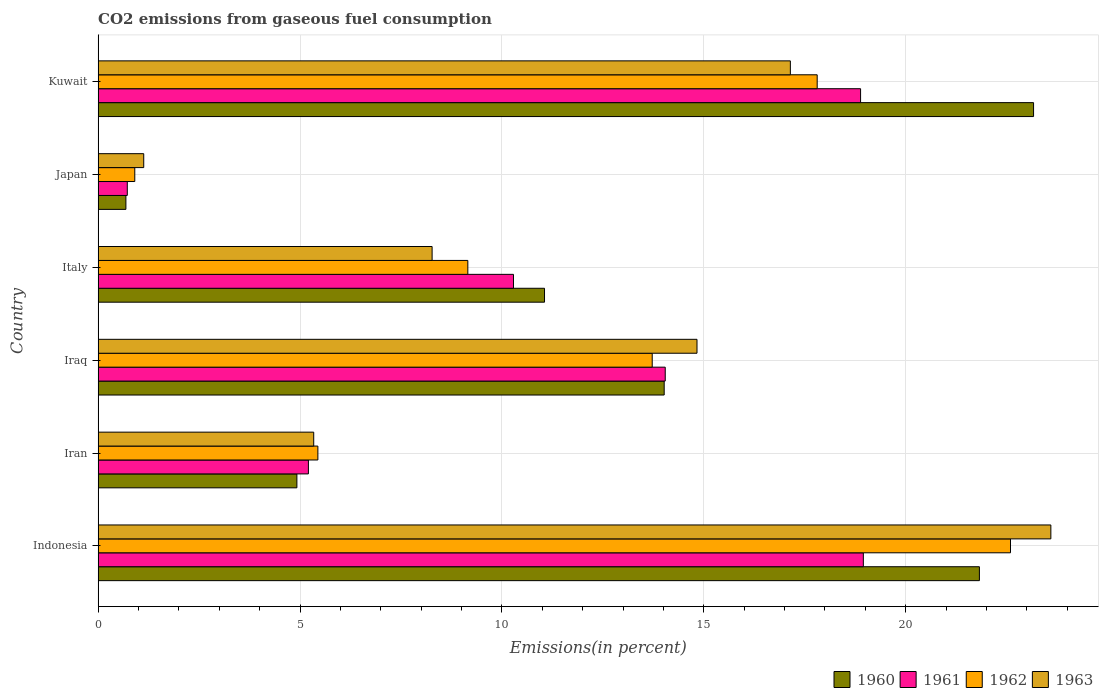How many different coloured bars are there?
Your response must be concise. 4. Are the number of bars on each tick of the Y-axis equal?
Give a very brief answer. Yes. How many bars are there on the 1st tick from the top?
Make the answer very short. 4. How many bars are there on the 5th tick from the bottom?
Provide a succinct answer. 4. What is the label of the 4th group of bars from the top?
Your answer should be very brief. Iraq. In how many cases, is the number of bars for a given country not equal to the number of legend labels?
Your answer should be compact. 0. What is the total CO2 emitted in 1963 in Italy?
Your answer should be compact. 8.27. Across all countries, what is the maximum total CO2 emitted in 1961?
Provide a succinct answer. 18.95. Across all countries, what is the minimum total CO2 emitted in 1960?
Your answer should be very brief. 0.69. In which country was the total CO2 emitted in 1962 maximum?
Your answer should be very brief. Indonesia. In which country was the total CO2 emitted in 1963 minimum?
Your answer should be compact. Japan. What is the total total CO2 emitted in 1960 in the graph?
Your answer should be very brief. 75.68. What is the difference between the total CO2 emitted in 1962 in Iran and that in Italy?
Ensure brevity in your answer.  -3.71. What is the difference between the total CO2 emitted in 1963 in Italy and the total CO2 emitted in 1961 in Indonesia?
Give a very brief answer. -10.68. What is the average total CO2 emitted in 1961 per country?
Provide a short and direct response. 11.35. What is the difference between the total CO2 emitted in 1962 and total CO2 emitted in 1961 in Kuwait?
Your answer should be very brief. -1.07. What is the ratio of the total CO2 emitted in 1960 in Japan to that in Kuwait?
Provide a succinct answer. 0.03. Is the difference between the total CO2 emitted in 1962 in Iran and Kuwait greater than the difference between the total CO2 emitted in 1961 in Iran and Kuwait?
Make the answer very short. Yes. What is the difference between the highest and the second highest total CO2 emitted in 1961?
Make the answer very short. 0.07. What is the difference between the highest and the lowest total CO2 emitted in 1961?
Provide a succinct answer. 18.23. In how many countries, is the total CO2 emitted in 1962 greater than the average total CO2 emitted in 1962 taken over all countries?
Your answer should be compact. 3. What does the 3rd bar from the bottom in Indonesia represents?
Provide a succinct answer. 1962. Is it the case that in every country, the sum of the total CO2 emitted in 1963 and total CO2 emitted in 1960 is greater than the total CO2 emitted in 1962?
Make the answer very short. Yes. Are all the bars in the graph horizontal?
Keep it short and to the point. Yes. How many countries are there in the graph?
Make the answer very short. 6. Are the values on the major ticks of X-axis written in scientific E-notation?
Offer a very short reply. No. Does the graph contain any zero values?
Ensure brevity in your answer.  No. How are the legend labels stacked?
Offer a very short reply. Horizontal. What is the title of the graph?
Make the answer very short. CO2 emissions from gaseous fuel consumption. What is the label or title of the X-axis?
Provide a succinct answer. Emissions(in percent). What is the label or title of the Y-axis?
Offer a very short reply. Country. What is the Emissions(in percent) in 1960 in Indonesia?
Provide a succinct answer. 21.83. What is the Emissions(in percent) in 1961 in Indonesia?
Your response must be concise. 18.95. What is the Emissions(in percent) in 1962 in Indonesia?
Ensure brevity in your answer.  22.6. What is the Emissions(in percent) in 1963 in Indonesia?
Provide a succinct answer. 23.6. What is the Emissions(in percent) of 1960 in Iran?
Your answer should be very brief. 4.92. What is the Emissions(in percent) in 1961 in Iran?
Keep it short and to the point. 5.21. What is the Emissions(in percent) of 1962 in Iran?
Your response must be concise. 5.44. What is the Emissions(in percent) in 1963 in Iran?
Provide a succinct answer. 5.34. What is the Emissions(in percent) in 1960 in Iraq?
Provide a succinct answer. 14.02. What is the Emissions(in percent) in 1961 in Iraq?
Offer a terse response. 14.05. What is the Emissions(in percent) of 1962 in Iraq?
Your answer should be very brief. 13.72. What is the Emissions(in percent) in 1963 in Iraq?
Make the answer very short. 14.83. What is the Emissions(in percent) in 1960 in Italy?
Your answer should be very brief. 11.06. What is the Emissions(in percent) in 1961 in Italy?
Ensure brevity in your answer.  10.29. What is the Emissions(in percent) in 1962 in Italy?
Keep it short and to the point. 9.16. What is the Emissions(in percent) of 1963 in Italy?
Offer a terse response. 8.27. What is the Emissions(in percent) in 1960 in Japan?
Keep it short and to the point. 0.69. What is the Emissions(in percent) of 1961 in Japan?
Provide a short and direct response. 0.72. What is the Emissions(in percent) of 1962 in Japan?
Offer a very short reply. 0.91. What is the Emissions(in percent) in 1963 in Japan?
Ensure brevity in your answer.  1.13. What is the Emissions(in percent) of 1960 in Kuwait?
Offer a terse response. 23.17. What is the Emissions(in percent) of 1961 in Kuwait?
Keep it short and to the point. 18.88. What is the Emissions(in percent) of 1962 in Kuwait?
Give a very brief answer. 17.81. What is the Emissions(in percent) of 1963 in Kuwait?
Provide a succinct answer. 17.14. Across all countries, what is the maximum Emissions(in percent) of 1960?
Your response must be concise. 23.17. Across all countries, what is the maximum Emissions(in percent) in 1961?
Make the answer very short. 18.95. Across all countries, what is the maximum Emissions(in percent) of 1962?
Ensure brevity in your answer.  22.6. Across all countries, what is the maximum Emissions(in percent) in 1963?
Keep it short and to the point. 23.6. Across all countries, what is the minimum Emissions(in percent) in 1960?
Make the answer very short. 0.69. Across all countries, what is the minimum Emissions(in percent) in 1961?
Provide a short and direct response. 0.72. Across all countries, what is the minimum Emissions(in percent) of 1962?
Offer a very short reply. 0.91. Across all countries, what is the minimum Emissions(in percent) of 1963?
Provide a succinct answer. 1.13. What is the total Emissions(in percent) of 1960 in the graph?
Offer a very short reply. 75.68. What is the total Emissions(in percent) in 1961 in the graph?
Offer a terse response. 68.1. What is the total Emissions(in percent) of 1962 in the graph?
Provide a short and direct response. 69.63. What is the total Emissions(in percent) in 1963 in the graph?
Your answer should be very brief. 70.31. What is the difference between the Emissions(in percent) in 1960 in Indonesia and that in Iran?
Make the answer very short. 16.9. What is the difference between the Emissions(in percent) of 1961 in Indonesia and that in Iran?
Offer a terse response. 13.74. What is the difference between the Emissions(in percent) in 1962 in Indonesia and that in Iran?
Offer a very short reply. 17.15. What is the difference between the Emissions(in percent) of 1963 in Indonesia and that in Iran?
Ensure brevity in your answer.  18.26. What is the difference between the Emissions(in percent) in 1960 in Indonesia and that in Iraq?
Offer a very short reply. 7.81. What is the difference between the Emissions(in percent) in 1961 in Indonesia and that in Iraq?
Provide a succinct answer. 4.91. What is the difference between the Emissions(in percent) in 1962 in Indonesia and that in Iraq?
Provide a short and direct response. 8.87. What is the difference between the Emissions(in percent) of 1963 in Indonesia and that in Iraq?
Keep it short and to the point. 8.76. What is the difference between the Emissions(in percent) of 1960 in Indonesia and that in Italy?
Keep it short and to the point. 10.77. What is the difference between the Emissions(in percent) in 1961 in Indonesia and that in Italy?
Offer a very short reply. 8.66. What is the difference between the Emissions(in percent) in 1962 in Indonesia and that in Italy?
Your response must be concise. 13.44. What is the difference between the Emissions(in percent) in 1963 in Indonesia and that in Italy?
Your answer should be very brief. 15.32. What is the difference between the Emissions(in percent) in 1960 in Indonesia and that in Japan?
Offer a terse response. 21.14. What is the difference between the Emissions(in percent) in 1961 in Indonesia and that in Japan?
Make the answer very short. 18.23. What is the difference between the Emissions(in percent) in 1962 in Indonesia and that in Japan?
Provide a succinct answer. 21.69. What is the difference between the Emissions(in percent) in 1963 in Indonesia and that in Japan?
Your answer should be very brief. 22.47. What is the difference between the Emissions(in percent) of 1960 in Indonesia and that in Kuwait?
Ensure brevity in your answer.  -1.34. What is the difference between the Emissions(in percent) of 1961 in Indonesia and that in Kuwait?
Make the answer very short. 0.07. What is the difference between the Emissions(in percent) of 1962 in Indonesia and that in Kuwait?
Offer a very short reply. 4.79. What is the difference between the Emissions(in percent) of 1963 in Indonesia and that in Kuwait?
Your response must be concise. 6.45. What is the difference between the Emissions(in percent) of 1960 in Iran and that in Iraq?
Your answer should be compact. -9.1. What is the difference between the Emissions(in percent) of 1961 in Iran and that in Iraq?
Your answer should be compact. -8.84. What is the difference between the Emissions(in percent) in 1962 in Iran and that in Iraq?
Offer a very short reply. -8.28. What is the difference between the Emissions(in percent) of 1963 in Iran and that in Iraq?
Your answer should be very brief. -9.49. What is the difference between the Emissions(in percent) in 1960 in Iran and that in Italy?
Offer a terse response. -6.13. What is the difference between the Emissions(in percent) in 1961 in Iran and that in Italy?
Make the answer very short. -5.08. What is the difference between the Emissions(in percent) of 1962 in Iran and that in Italy?
Your response must be concise. -3.71. What is the difference between the Emissions(in percent) of 1963 in Iran and that in Italy?
Your answer should be very brief. -2.93. What is the difference between the Emissions(in percent) in 1960 in Iran and that in Japan?
Provide a succinct answer. 4.23. What is the difference between the Emissions(in percent) of 1961 in Iran and that in Japan?
Keep it short and to the point. 4.49. What is the difference between the Emissions(in percent) of 1962 in Iran and that in Japan?
Provide a short and direct response. 4.53. What is the difference between the Emissions(in percent) of 1963 in Iran and that in Japan?
Provide a succinct answer. 4.21. What is the difference between the Emissions(in percent) in 1960 in Iran and that in Kuwait?
Provide a short and direct response. -18.24. What is the difference between the Emissions(in percent) in 1961 in Iran and that in Kuwait?
Offer a very short reply. -13.67. What is the difference between the Emissions(in percent) of 1962 in Iran and that in Kuwait?
Give a very brief answer. -12.37. What is the difference between the Emissions(in percent) in 1963 in Iran and that in Kuwait?
Offer a very short reply. -11.8. What is the difference between the Emissions(in percent) of 1960 in Iraq and that in Italy?
Ensure brevity in your answer.  2.96. What is the difference between the Emissions(in percent) of 1961 in Iraq and that in Italy?
Your response must be concise. 3.76. What is the difference between the Emissions(in percent) of 1962 in Iraq and that in Italy?
Give a very brief answer. 4.57. What is the difference between the Emissions(in percent) in 1963 in Iraq and that in Italy?
Your response must be concise. 6.56. What is the difference between the Emissions(in percent) of 1960 in Iraq and that in Japan?
Offer a terse response. 13.33. What is the difference between the Emissions(in percent) in 1961 in Iraq and that in Japan?
Provide a short and direct response. 13.32. What is the difference between the Emissions(in percent) in 1962 in Iraq and that in Japan?
Your answer should be very brief. 12.82. What is the difference between the Emissions(in percent) of 1963 in Iraq and that in Japan?
Your response must be concise. 13.7. What is the difference between the Emissions(in percent) of 1960 in Iraq and that in Kuwait?
Offer a very short reply. -9.15. What is the difference between the Emissions(in percent) in 1961 in Iraq and that in Kuwait?
Give a very brief answer. -4.84. What is the difference between the Emissions(in percent) of 1962 in Iraq and that in Kuwait?
Keep it short and to the point. -4.09. What is the difference between the Emissions(in percent) of 1963 in Iraq and that in Kuwait?
Offer a very short reply. -2.31. What is the difference between the Emissions(in percent) of 1960 in Italy and that in Japan?
Offer a very short reply. 10.37. What is the difference between the Emissions(in percent) of 1961 in Italy and that in Japan?
Your answer should be compact. 9.56. What is the difference between the Emissions(in percent) in 1962 in Italy and that in Japan?
Make the answer very short. 8.25. What is the difference between the Emissions(in percent) in 1963 in Italy and that in Japan?
Offer a very short reply. 7.14. What is the difference between the Emissions(in percent) of 1960 in Italy and that in Kuwait?
Your answer should be compact. -12.11. What is the difference between the Emissions(in percent) in 1961 in Italy and that in Kuwait?
Make the answer very short. -8.6. What is the difference between the Emissions(in percent) in 1962 in Italy and that in Kuwait?
Give a very brief answer. -8.65. What is the difference between the Emissions(in percent) of 1963 in Italy and that in Kuwait?
Give a very brief answer. -8.87. What is the difference between the Emissions(in percent) of 1960 in Japan and that in Kuwait?
Give a very brief answer. -22.48. What is the difference between the Emissions(in percent) of 1961 in Japan and that in Kuwait?
Provide a short and direct response. -18.16. What is the difference between the Emissions(in percent) of 1962 in Japan and that in Kuwait?
Offer a terse response. -16.9. What is the difference between the Emissions(in percent) in 1963 in Japan and that in Kuwait?
Keep it short and to the point. -16.01. What is the difference between the Emissions(in percent) of 1960 in Indonesia and the Emissions(in percent) of 1961 in Iran?
Your response must be concise. 16.62. What is the difference between the Emissions(in percent) of 1960 in Indonesia and the Emissions(in percent) of 1962 in Iran?
Make the answer very short. 16.38. What is the difference between the Emissions(in percent) of 1960 in Indonesia and the Emissions(in percent) of 1963 in Iran?
Your response must be concise. 16.49. What is the difference between the Emissions(in percent) of 1961 in Indonesia and the Emissions(in percent) of 1962 in Iran?
Your response must be concise. 13.51. What is the difference between the Emissions(in percent) of 1961 in Indonesia and the Emissions(in percent) of 1963 in Iran?
Offer a terse response. 13.61. What is the difference between the Emissions(in percent) of 1962 in Indonesia and the Emissions(in percent) of 1963 in Iran?
Provide a short and direct response. 17.26. What is the difference between the Emissions(in percent) of 1960 in Indonesia and the Emissions(in percent) of 1961 in Iraq?
Provide a succinct answer. 7.78. What is the difference between the Emissions(in percent) of 1960 in Indonesia and the Emissions(in percent) of 1962 in Iraq?
Provide a short and direct response. 8.1. What is the difference between the Emissions(in percent) of 1960 in Indonesia and the Emissions(in percent) of 1963 in Iraq?
Make the answer very short. 6.99. What is the difference between the Emissions(in percent) of 1961 in Indonesia and the Emissions(in percent) of 1962 in Iraq?
Offer a very short reply. 5.23. What is the difference between the Emissions(in percent) in 1961 in Indonesia and the Emissions(in percent) in 1963 in Iraq?
Ensure brevity in your answer.  4.12. What is the difference between the Emissions(in percent) of 1962 in Indonesia and the Emissions(in percent) of 1963 in Iraq?
Provide a short and direct response. 7.76. What is the difference between the Emissions(in percent) in 1960 in Indonesia and the Emissions(in percent) in 1961 in Italy?
Provide a succinct answer. 11.54. What is the difference between the Emissions(in percent) in 1960 in Indonesia and the Emissions(in percent) in 1962 in Italy?
Give a very brief answer. 12.67. What is the difference between the Emissions(in percent) of 1960 in Indonesia and the Emissions(in percent) of 1963 in Italy?
Your answer should be very brief. 13.55. What is the difference between the Emissions(in percent) in 1961 in Indonesia and the Emissions(in percent) in 1962 in Italy?
Your answer should be compact. 9.8. What is the difference between the Emissions(in percent) in 1961 in Indonesia and the Emissions(in percent) in 1963 in Italy?
Provide a succinct answer. 10.68. What is the difference between the Emissions(in percent) of 1962 in Indonesia and the Emissions(in percent) of 1963 in Italy?
Provide a succinct answer. 14.32. What is the difference between the Emissions(in percent) in 1960 in Indonesia and the Emissions(in percent) in 1961 in Japan?
Keep it short and to the point. 21.1. What is the difference between the Emissions(in percent) in 1960 in Indonesia and the Emissions(in percent) in 1962 in Japan?
Give a very brief answer. 20.92. What is the difference between the Emissions(in percent) of 1960 in Indonesia and the Emissions(in percent) of 1963 in Japan?
Your response must be concise. 20.7. What is the difference between the Emissions(in percent) in 1961 in Indonesia and the Emissions(in percent) in 1962 in Japan?
Your response must be concise. 18.04. What is the difference between the Emissions(in percent) of 1961 in Indonesia and the Emissions(in percent) of 1963 in Japan?
Your answer should be compact. 17.82. What is the difference between the Emissions(in percent) of 1962 in Indonesia and the Emissions(in percent) of 1963 in Japan?
Make the answer very short. 21.47. What is the difference between the Emissions(in percent) of 1960 in Indonesia and the Emissions(in percent) of 1961 in Kuwait?
Provide a succinct answer. 2.94. What is the difference between the Emissions(in percent) of 1960 in Indonesia and the Emissions(in percent) of 1962 in Kuwait?
Your response must be concise. 4.02. What is the difference between the Emissions(in percent) of 1960 in Indonesia and the Emissions(in percent) of 1963 in Kuwait?
Make the answer very short. 4.68. What is the difference between the Emissions(in percent) in 1961 in Indonesia and the Emissions(in percent) in 1962 in Kuwait?
Ensure brevity in your answer.  1.14. What is the difference between the Emissions(in percent) of 1961 in Indonesia and the Emissions(in percent) of 1963 in Kuwait?
Provide a short and direct response. 1.81. What is the difference between the Emissions(in percent) of 1962 in Indonesia and the Emissions(in percent) of 1963 in Kuwait?
Your answer should be very brief. 5.45. What is the difference between the Emissions(in percent) of 1960 in Iran and the Emissions(in percent) of 1961 in Iraq?
Provide a succinct answer. -9.12. What is the difference between the Emissions(in percent) in 1960 in Iran and the Emissions(in percent) in 1962 in Iraq?
Offer a very short reply. -8.8. What is the difference between the Emissions(in percent) in 1960 in Iran and the Emissions(in percent) in 1963 in Iraq?
Your answer should be compact. -9.91. What is the difference between the Emissions(in percent) of 1961 in Iran and the Emissions(in percent) of 1962 in Iraq?
Your answer should be very brief. -8.51. What is the difference between the Emissions(in percent) in 1961 in Iran and the Emissions(in percent) in 1963 in Iraq?
Your answer should be compact. -9.62. What is the difference between the Emissions(in percent) of 1962 in Iran and the Emissions(in percent) of 1963 in Iraq?
Ensure brevity in your answer.  -9.39. What is the difference between the Emissions(in percent) of 1960 in Iran and the Emissions(in percent) of 1961 in Italy?
Your answer should be compact. -5.36. What is the difference between the Emissions(in percent) in 1960 in Iran and the Emissions(in percent) in 1962 in Italy?
Offer a terse response. -4.23. What is the difference between the Emissions(in percent) of 1960 in Iran and the Emissions(in percent) of 1963 in Italy?
Your answer should be very brief. -3.35. What is the difference between the Emissions(in percent) in 1961 in Iran and the Emissions(in percent) in 1962 in Italy?
Offer a terse response. -3.95. What is the difference between the Emissions(in percent) in 1961 in Iran and the Emissions(in percent) in 1963 in Italy?
Offer a terse response. -3.06. What is the difference between the Emissions(in percent) in 1962 in Iran and the Emissions(in percent) in 1963 in Italy?
Your response must be concise. -2.83. What is the difference between the Emissions(in percent) in 1960 in Iran and the Emissions(in percent) in 1961 in Japan?
Your answer should be very brief. 4.2. What is the difference between the Emissions(in percent) in 1960 in Iran and the Emissions(in percent) in 1962 in Japan?
Your answer should be very brief. 4.02. What is the difference between the Emissions(in percent) of 1960 in Iran and the Emissions(in percent) of 1963 in Japan?
Provide a succinct answer. 3.79. What is the difference between the Emissions(in percent) in 1961 in Iran and the Emissions(in percent) in 1962 in Japan?
Your answer should be compact. 4.3. What is the difference between the Emissions(in percent) in 1961 in Iran and the Emissions(in percent) in 1963 in Japan?
Ensure brevity in your answer.  4.08. What is the difference between the Emissions(in percent) of 1962 in Iran and the Emissions(in percent) of 1963 in Japan?
Your response must be concise. 4.31. What is the difference between the Emissions(in percent) of 1960 in Iran and the Emissions(in percent) of 1961 in Kuwait?
Ensure brevity in your answer.  -13.96. What is the difference between the Emissions(in percent) of 1960 in Iran and the Emissions(in percent) of 1962 in Kuwait?
Give a very brief answer. -12.89. What is the difference between the Emissions(in percent) of 1960 in Iran and the Emissions(in percent) of 1963 in Kuwait?
Provide a short and direct response. -12.22. What is the difference between the Emissions(in percent) of 1961 in Iran and the Emissions(in percent) of 1962 in Kuwait?
Your answer should be very brief. -12.6. What is the difference between the Emissions(in percent) in 1961 in Iran and the Emissions(in percent) in 1963 in Kuwait?
Your answer should be very brief. -11.94. What is the difference between the Emissions(in percent) of 1962 in Iran and the Emissions(in percent) of 1963 in Kuwait?
Your answer should be very brief. -11.7. What is the difference between the Emissions(in percent) in 1960 in Iraq and the Emissions(in percent) in 1961 in Italy?
Provide a short and direct response. 3.73. What is the difference between the Emissions(in percent) in 1960 in Iraq and the Emissions(in percent) in 1962 in Italy?
Give a very brief answer. 4.86. What is the difference between the Emissions(in percent) in 1960 in Iraq and the Emissions(in percent) in 1963 in Italy?
Ensure brevity in your answer.  5.75. What is the difference between the Emissions(in percent) in 1961 in Iraq and the Emissions(in percent) in 1962 in Italy?
Provide a short and direct response. 4.89. What is the difference between the Emissions(in percent) in 1961 in Iraq and the Emissions(in percent) in 1963 in Italy?
Your answer should be very brief. 5.77. What is the difference between the Emissions(in percent) of 1962 in Iraq and the Emissions(in percent) of 1963 in Italy?
Make the answer very short. 5.45. What is the difference between the Emissions(in percent) in 1960 in Iraq and the Emissions(in percent) in 1961 in Japan?
Your response must be concise. 13.3. What is the difference between the Emissions(in percent) in 1960 in Iraq and the Emissions(in percent) in 1962 in Japan?
Your answer should be very brief. 13.11. What is the difference between the Emissions(in percent) of 1960 in Iraq and the Emissions(in percent) of 1963 in Japan?
Offer a terse response. 12.89. What is the difference between the Emissions(in percent) in 1961 in Iraq and the Emissions(in percent) in 1962 in Japan?
Your answer should be very brief. 13.14. What is the difference between the Emissions(in percent) in 1961 in Iraq and the Emissions(in percent) in 1963 in Japan?
Your response must be concise. 12.92. What is the difference between the Emissions(in percent) in 1962 in Iraq and the Emissions(in percent) in 1963 in Japan?
Ensure brevity in your answer.  12.59. What is the difference between the Emissions(in percent) of 1960 in Iraq and the Emissions(in percent) of 1961 in Kuwait?
Your answer should be very brief. -4.86. What is the difference between the Emissions(in percent) of 1960 in Iraq and the Emissions(in percent) of 1962 in Kuwait?
Ensure brevity in your answer.  -3.79. What is the difference between the Emissions(in percent) of 1960 in Iraq and the Emissions(in percent) of 1963 in Kuwait?
Offer a very short reply. -3.12. What is the difference between the Emissions(in percent) in 1961 in Iraq and the Emissions(in percent) in 1962 in Kuwait?
Your response must be concise. -3.76. What is the difference between the Emissions(in percent) of 1961 in Iraq and the Emissions(in percent) of 1963 in Kuwait?
Offer a very short reply. -3.1. What is the difference between the Emissions(in percent) of 1962 in Iraq and the Emissions(in percent) of 1963 in Kuwait?
Provide a succinct answer. -3.42. What is the difference between the Emissions(in percent) in 1960 in Italy and the Emissions(in percent) in 1961 in Japan?
Your answer should be very brief. 10.33. What is the difference between the Emissions(in percent) in 1960 in Italy and the Emissions(in percent) in 1962 in Japan?
Offer a terse response. 10.15. What is the difference between the Emissions(in percent) in 1960 in Italy and the Emissions(in percent) in 1963 in Japan?
Provide a short and direct response. 9.93. What is the difference between the Emissions(in percent) of 1961 in Italy and the Emissions(in percent) of 1962 in Japan?
Your response must be concise. 9.38. What is the difference between the Emissions(in percent) of 1961 in Italy and the Emissions(in percent) of 1963 in Japan?
Ensure brevity in your answer.  9.16. What is the difference between the Emissions(in percent) of 1962 in Italy and the Emissions(in percent) of 1963 in Japan?
Keep it short and to the point. 8.03. What is the difference between the Emissions(in percent) in 1960 in Italy and the Emissions(in percent) in 1961 in Kuwait?
Provide a short and direct response. -7.83. What is the difference between the Emissions(in percent) of 1960 in Italy and the Emissions(in percent) of 1962 in Kuwait?
Your answer should be compact. -6.75. What is the difference between the Emissions(in percent) in 1960 in Italy and the Emissions(in percent) in 1963 in Kuwait?
Your answer should be very brief. -6.09. What is the difference between the Emissions(in percent) in 1961 in Italy and the Emissions(in percent) in 1962 in Kuwait?
Make the answer very short. -7.52. What is the difference between the Emissions(in percent) of 1961 in Italy and the Emissions(in percent) of 1963 in Kuwait?
Keep it short and to the point. -6.86. What is the difference between the Emissions(in percent) in 1962 in Italy and the Emissions(in percent) in 1963 in Kuwait?
Your answer should be very brief. -7.99. What is the difference between the Emissions(in percent) of 1960 in Japan and the Emissions(in percent) of 1961 in Kuwait?
Make the answer very short. -18.19. What is the difference between the Emissions(in percent) of 1960 in Japan and the Emissions(in percent) of 1962 in Kuwait?
Your response must be concise. -17.12. What is the difference between the Emissions(in percent) of 1960 in Japan and the Emissions(in percent) of 1963 in Kuwait?
Your response must be concise. -16.46. What is the difference between the Emissions(in percent) of 1961 in Japan and the Emissions(in percent) of 1962 in Kuwait?
Provide a succinct answer. -17.09. What is the difference between the Emissions(in percent) in 1961 in Japan and the Emissions(in percent) in 1963 in Kuwait?
Ensure brevity in your answer.  -16.42. What is the difference between the Emissions(in percent) in 1962 in Japan and the Emissions(in percent) in 1963 in Kuwait?
Offer a very short reply. -16.24. What is the average Emissions(in percent) in 1960 per country?
Offer a very short reply. 12.61. What is the average Emissions(in percent) of 1961 per country?
Provide a succinct answer. 11.35. What is the average Emissions(in percent) of 1962 per country?
Keep it short and to the point. 11.61. What is the average Emissions(in percent) in 1963 per country?
Make the answer very short. 11.72. What is the difference between the Emissions(in percent) of 1960 and Emissions(in percent) of 1961 in Indonesia?
Provide a succinct answer. 2.87. What is the difference between the Emissions(in percent) of 1960 and Emissions(in percent) of 1962 in Indonesia?
Your response must be concise. -0.77. What is the difference between the Emissions(in percent) of 1960 and Emissions(in percent) of 1963 in Indonesia?
Ensure brevity in your answer.  -1.77. What is the difference between the Emissions(in percent) of 1961 and Emissions(in percent) of 1962 in Indonesia?
Provide a succinct answer. -3.64. What is the difference between the Emissions(in percent) in 1961 and Emissions(in percent) in 1963 in Indonesia?
Keep it short and to the point. -4.64. What is the difference between the Emissions(in percent) of 1962 and Emissions(in percent) of 1963 in Indonesia?
Give a very brief answer. -1. What is the difference between the Emissions(in percent) in 1960 and Emissions(in percent) in 1961 in Iran?
Give a very brief answer. -0.29. What is the difference between the Emissions(in percent) of 1960 and Emissions(in percent) of 1962 in Iran?
Your response must be concise. -0.52. What is the difference between the Emissions(in percent) in 1960 and Emissions(in percent) in 1963 in Iran?
Offer a terse response. -0.42. What is the difference between the Emissions(in percent) in 1961 and Emissions(in percent) in 1962 in Iran?
Keep it short and to the point. -0.23. What is the difference between the Emissions(in percent) in 1961 and Emissions(in percent) in 1963 in Iran?
Your response must be concise. -0.13. What is the difference between the Emissions(in percent) of 1962 and Emissions(in percent) of 1963 in Iran?
Your answer should be very brief. 0.1. What is the difference between the Emissions(in percent) of 1960 and Emissions(in percent) of 1961 in Iraq?
Provide a succinct answer. -0.03. What is the difference between the Emissions(in percent) in 1960 and Emissions(in percent) in 1962 in Iraq?
Offer a very short reply. 0.3. What is the difference between the Emissions(in percent) in 1960 and Emissions(in percent) in 1963 in Iraq?
Keep it short and to the point. -0.81. What is the difference between the Emissions(in percent) of 1961 and Emissions(in percent) of 1962 in Iraq?
Your answer should be compact. 0.32. What is the difference between the Emissions(in percent) in 1961 and Emissions(in percent) in 1963 in Iraq?
Provide a succinct answer. -0.79. What is the difference between the Emissions(in percent) in 1962 and Emissions(in percent) in 1963 in Iraq?
Give a very brief answer. -1.11. What is the difference between the Emissions(in percent) in 1960 and Emissions(in percent) in 1961 in Italy?
Provide a short and direct response. 0.77. What is the difference between the Emissions(in percent) of 1960 and Emissions(in percent) of 1962 in Italy?
Your response must be concise. 1.9. What is the difference between the Emissions(in percent) in 1960 and Emissions(in percent) in 1963 in Italy?
Your response must be concise. 2.78. What is the difference between the Emissions(in percent) of 1961 and Emissions(in percent) of 1962 in Italy?
Ensure brevity in your answer.  1.13. What is the difference between the Emissions(in percent) in 1961 and Emissions(in percent) in 1963 in Italy?
Offer a very short reply. 2.02. What is the difference between the Emissions(in percent) in 1962 and Emissions(in percent) in 1963 in Italy?
Your answer should be very brief. 0.88. What is the difference between the Emissions(in percent) of 1960 and Emissions(in percent) of 1961 in Japan?
Provide a short and direct response. -0.03. What is the difference between the Emissions(in percent) of 1960 and Emissions(in percent) of 1962 in Japan?
Make the answer very short. -0.22. What is the difference between the Emissions(in percent) of 1960 and Emissions(in percent) of 1963 in Japan?
Ensure brevity in your answer.  -0.44. What is the difference between the Emissions(in percent) of 1961 and Emissions(in percent) of 1962 in Japan?
Your response must be concise. -0.19. What is the difference between the Emissions(in percent) of 1961 and Emissions(in percent) of 1963 in Japan?
Offer a terse response. -0.41. What is the difference between the Emissions(in percent) in 1962 and Emissions(in percent) in 1963 in Japan?
Your answer should be very brief. -0.22. What is the difference between the Emissions(in percent) of 1960 and Emissions(in percent) of 1961 in Kuwait?
Offer a very short reply. 4.28. What is the difference between the Emissions(in percent) of 1960 and Emissions(in percent) of 1962 in Kuwait?
Provide a succinct answer. 5.36. What is the difference between the Emissions(in percent) in 1960 and Emissions(in percent) in 1963 in Kuwait?
Give a very brief answer. 6.02. What is the difference between the Emissions(in percent) in 1961 and Emissions(in percent) in 1962 in Kuwait?
Your response must be concise. 1.07. What is the difference between the Emissions(in percent) in 1961 and Emissions(in percent) in 1963 in Kuwait?
Your response must be concise. 1.74. What is the difference between the Emissions(in percent) in 1962 and Emissions(in percent) in 1963 in Kuwait?
Keep it short and to the point. 0.66. What is the ratio of the Emissions(in percent) in 1960 in Indonesia to that in Iran?
Your response must be concise. 4.43. What is the ratio of the Emissions(in percent) of 1961 in Indonesia to that in Iran?
Provide a short and direct response. 3.64. What is the ratio of the Emissions(in percent) of 1962 in Indonesia to that in Iran?
Provide a succinct answer. 4.15. What is the ratio of the Emissions(in percent) in 1963 in Indonesia to that in Iran?
Provide a succinct answer. 4.42. What is the ratio of the Emissions(in percent) in 1960 in Indonesia to that in Iraq?
Offer a very short reply. 1.56. What is the ratio of the Emissions(in percent) of 1961 in Indonesia to that in Iraq?
Offer a very short reply. 1.35. What is the ratio of the Emissions(in percent) in 1962 in Indonesia to that in Iraq?
Provide a succinct answer. 1.65. What is the ratio of the Emissions(in percent) in 1963 in Indonesia to that in Iraq?
Your answer should be very brief. 1.59. What is the ratio of the Emissions(in percent) in 1960 in Indonesia to that in Italy?
Your response must be concise. 1.97. What is the ratio of the Emissions(in percent) of 1961 in Indonesia to that in Italy?
Your answer should be very brief. 1.84. What is the ratio of the Emissions(in percent) of 1962 in Indonesia to that in Italy?
Your answer should be very brief. 2.47. What is the ratio of the Emissions(in percent) in 1963 in Indonesia to that in Italy?
Your response must be concise. 2.85. What is the ratio of the Emissions(in percent) in 1960 in Indonesia to that in Japan?
Offer a very short reply. 31.71. What is the ratio of the Emissions(in percent) in 1961 in Indonesia to that in Japan?
Keep it short and to the point. 26.22. What is the ratio of the Emissions(in percent) in 1962 in Indonesia to that in Japan?
Your response must be concise. 24.89. What is the ratio of the Emissions(in percent) in 1963 in Indonesia to that in Japan?
Provide a succinct answer. 20.89. What is the ratio of the Emissions(in percent) in 1960 in Indonesia to that in Kuwait?
Keep it short and to the point. 0.94. What is the ratio of the Emissions(in percent) of 1962 in Indonesia to that in Kuwait?
Make the answer very short. 1.27. What is the ratio of the Emissions(in percent) in 1963 in Indonesia to that in Kuwait?
Your answer should be very brief. 1.38. What is the ratio of the Emissions(in percent) of 1960 in Iran to that in Iraq?
Your answer should be compact. 0.35. What is the ratio of the Emissions(in percent) of 1961 in Iran to that in Iraq?
Offer a terse response. 0.37. What is the ratio of the Emissions(in percent) in 1962 in Iran to that in Iraq?
Provide a succinct answer. 0.4. What is the ratio of the Emissions(in percent) of 1963 in Iran to that in Iraq?
Keep it short and to the point. 0.36. What is the ratio of the Emissions(in percent) in 1960 in Iran to that in Italy?
Provide a short and direct response. 0.45. What is the ratio of the Emissions(in percent) in 1961 in Iran to that in Italy?
Make the answer very short. 0.51. What is the ratio of the Emissions(in percent) of 1962 in Iran to that in Italy?
Ensure brevity in your answer.  0.59. What is the ratio of the Emissions(in percent) in 1963 in Iran to that in Italy?
Offer a terse response. 0.65. What is the ratio of the Emissions(in percent) in 1960 in Iran to that in Japan?
Provide a succinct answer. 7.15. What is the ratio of the Emissions(in percent) in 1961 in Iran to that in Japan?
Make the answer very short. 7.21. What is the ratio of the Emissions(in percent) of 1962 in Iran to that in Japan?
Your response must be concise. 5.99. What is the ratio of the Emissions(in percent) of 1963 in Iran to that in Japan?
Ensure brevity in your answer.  4.73. What is the ratio of the Emissions(in percent) of 1960 in Iran to that in Kuwait?
Offer a very short reply. 0.21. What is the ratio of the Emissions(in percent) of 1961 in Iran to that in Kuwait?
Your answer should be compact. 0.28. What is the ratio of the Emissions(in percent) in 1962 in Iran to that in Kuwait?
Your response must be concise. 0.31. What is the ratio of the Emissions(in percent) in 1963 in Iran to that in Kuwait?
Your response must be concise. 0.31. What is the ratio of the Emissions(in percent) of 1960 in Iraq to that in Italy?
Your answer should be compact. 1.27. What is the ratio of the Emissions(in percent) in 1961 in Iraq to that in Italy?
Your answer should be compact. 1.37. What is the ratio of the Emissions(in percent) in 1962 in Iraq to that in Italy?
Provide a succinct answer. 1.5. What is the ratio of the Emissions(in percent) of 1963 in Iraq to that in Italy?
Your response must be concise. 1.79. What is the ratio of the Emissions(in percent) in 1960 in Iraq to that in Japan?
Ensure brevity in your answer.  20.37. What is the ratio of the Emissions(in percent) of 1961 in Iraq to that in Japan?
Offer a terse response. 19.43. What is the ratio of the Emissions(in percent) in 1962 in Iraq to that in Japan?
Provide a short and direct response. 15.11. What is the ratio of the Emissions(in percent) in 1963 in Iraq to that in Japan?
Keep it short and to the point. 13.13. What is the ratio of the Emissions(in percent) in 1960 in Iraq to that in Kuwait?
Your response must be concise. 0.61. What is the ratio of the Emissions(in percent) in 1961 in Iraq to that in Kuwait?
Give a very brief answer. 0.74. What is the ratio of the Emissions(in percent) in 1962 in Iraq to that in Kuwait?
Provide a short and direct response. 0.77. What is the ratio of the Emissions(in percent) in 1963 in Iraq to that in Kuwait?
Offer a terse response. 0.87. What is the ratio of the Emissions(in percent) of 1960 in Italy to that in Japan?
Offer a terse response. 16.06. What is the ratio of the Emissions(in percent) of 1961 in Italy to that in Japan?
Ensure brevity in your answer.  14.23. What is the ratio of the Emissions(in percent) in 1962 in Italy to that in Japan?
Offer a very short reply. 10.09. What is the ratio of the Emissions(in percent) of 1963 in Italy to that in Japan?
Provide a short and direct response. 7.32. What is the ratio of the Emissions(in percent) of 1960 in Italy to that in Kuwait?
Your answer should be compact. 0.48. What is the ratio of the Emissions(in percent) of 1961 in Italy to that in Kuwait?
Keep it short and to the point. 0.54. What is the ratio of the Emissions(in percent) in 1962 in Italy to that in Kuwait?
Make the answer very short. 0.51. What is the ratio of the Emissions(in percent) in 1963 in Italy to that in Kuwait?
Your response must be concise. 0.48. What is the ratio of the Emissions(in percent) of 1960 in Japan to that in Kuwait?
Offer a terse response. 0.03. What is the ratio of the Emissions(in percent) in 1961 in Japan to that in Kuwait?
Your answer should be very brief. 0.04. What is the ratio of the Emissions(in percent) of 1962 in Japan to that in Kuwait?
Make the answer very short. 0.05. What is the ratio of the Emissions(in percent) in 1963 in Japan to that in Kuwait?
Provide a succinct answer. 0.07. What is the difference between the highest and the second highest Emissions(in percent) in 1960?
Provide a short and direct response. 1.34. What is the difference between the highest and the second highest Emissions(in percent) of 1961?
Keep it short and to the point. 0.07. What is the difference between the highest and the second highest Emissions(in percent) of 1962?
Offer a terse response. 4.79. What is the difference between the highest and the second highest Emissions(in percent) of 1963?
Offer a very short reply. 6.45. What is the difference between the highest and the lowest Emissions(in percent) of 1960?
Keep it short and to the point. 22.48. What is the difference between the highest and the lowest Emissions(in percent) of 1961?
Make the answer very short. 18.23. What is the difference between the highest and the lowest Emissions(in percent) of 1962?
Keep it short and to the point. 21.69. What is the difference between the highest and the lowest Emissions(in percent) of 1963?
Offer a very short reply. 22.47. 